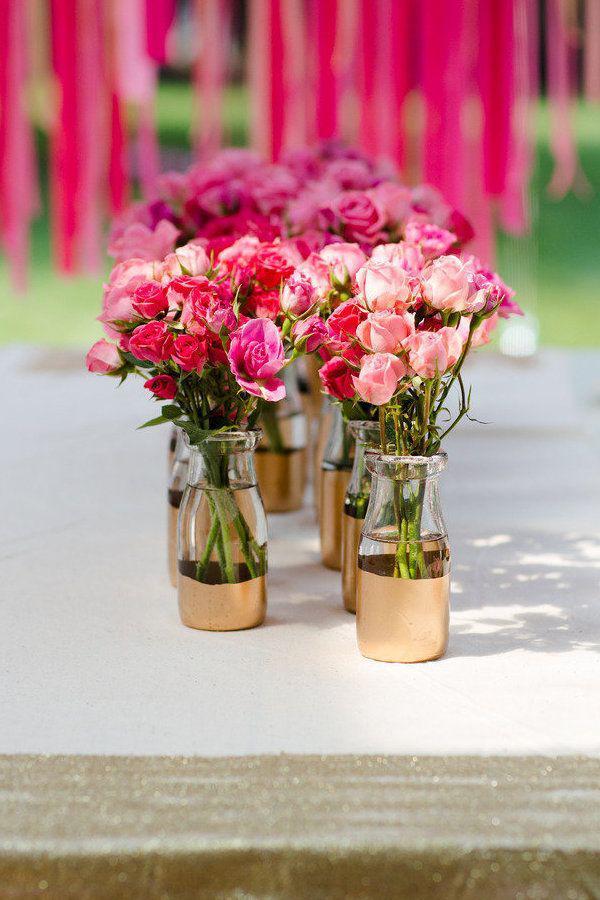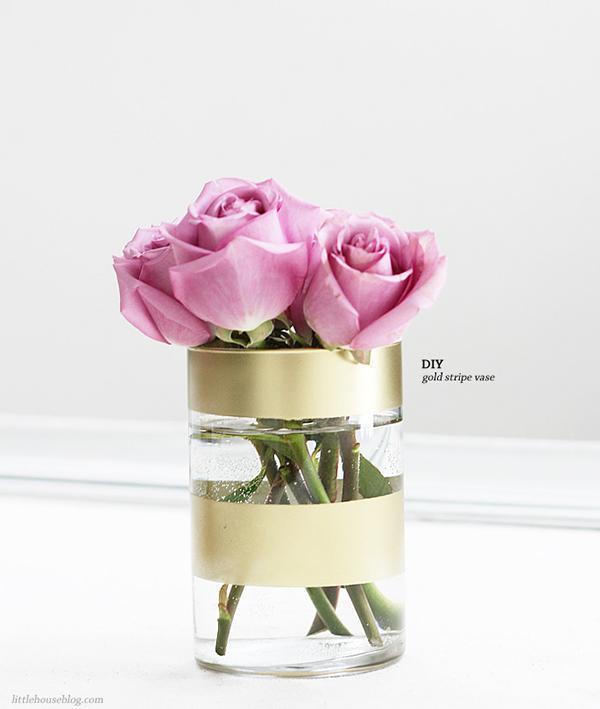The first image is the image on the left, the second image is the image on the right. Considering the images on both sides, is "There are more vases in the image on the left." valid? Answer yes or no. Yes. 